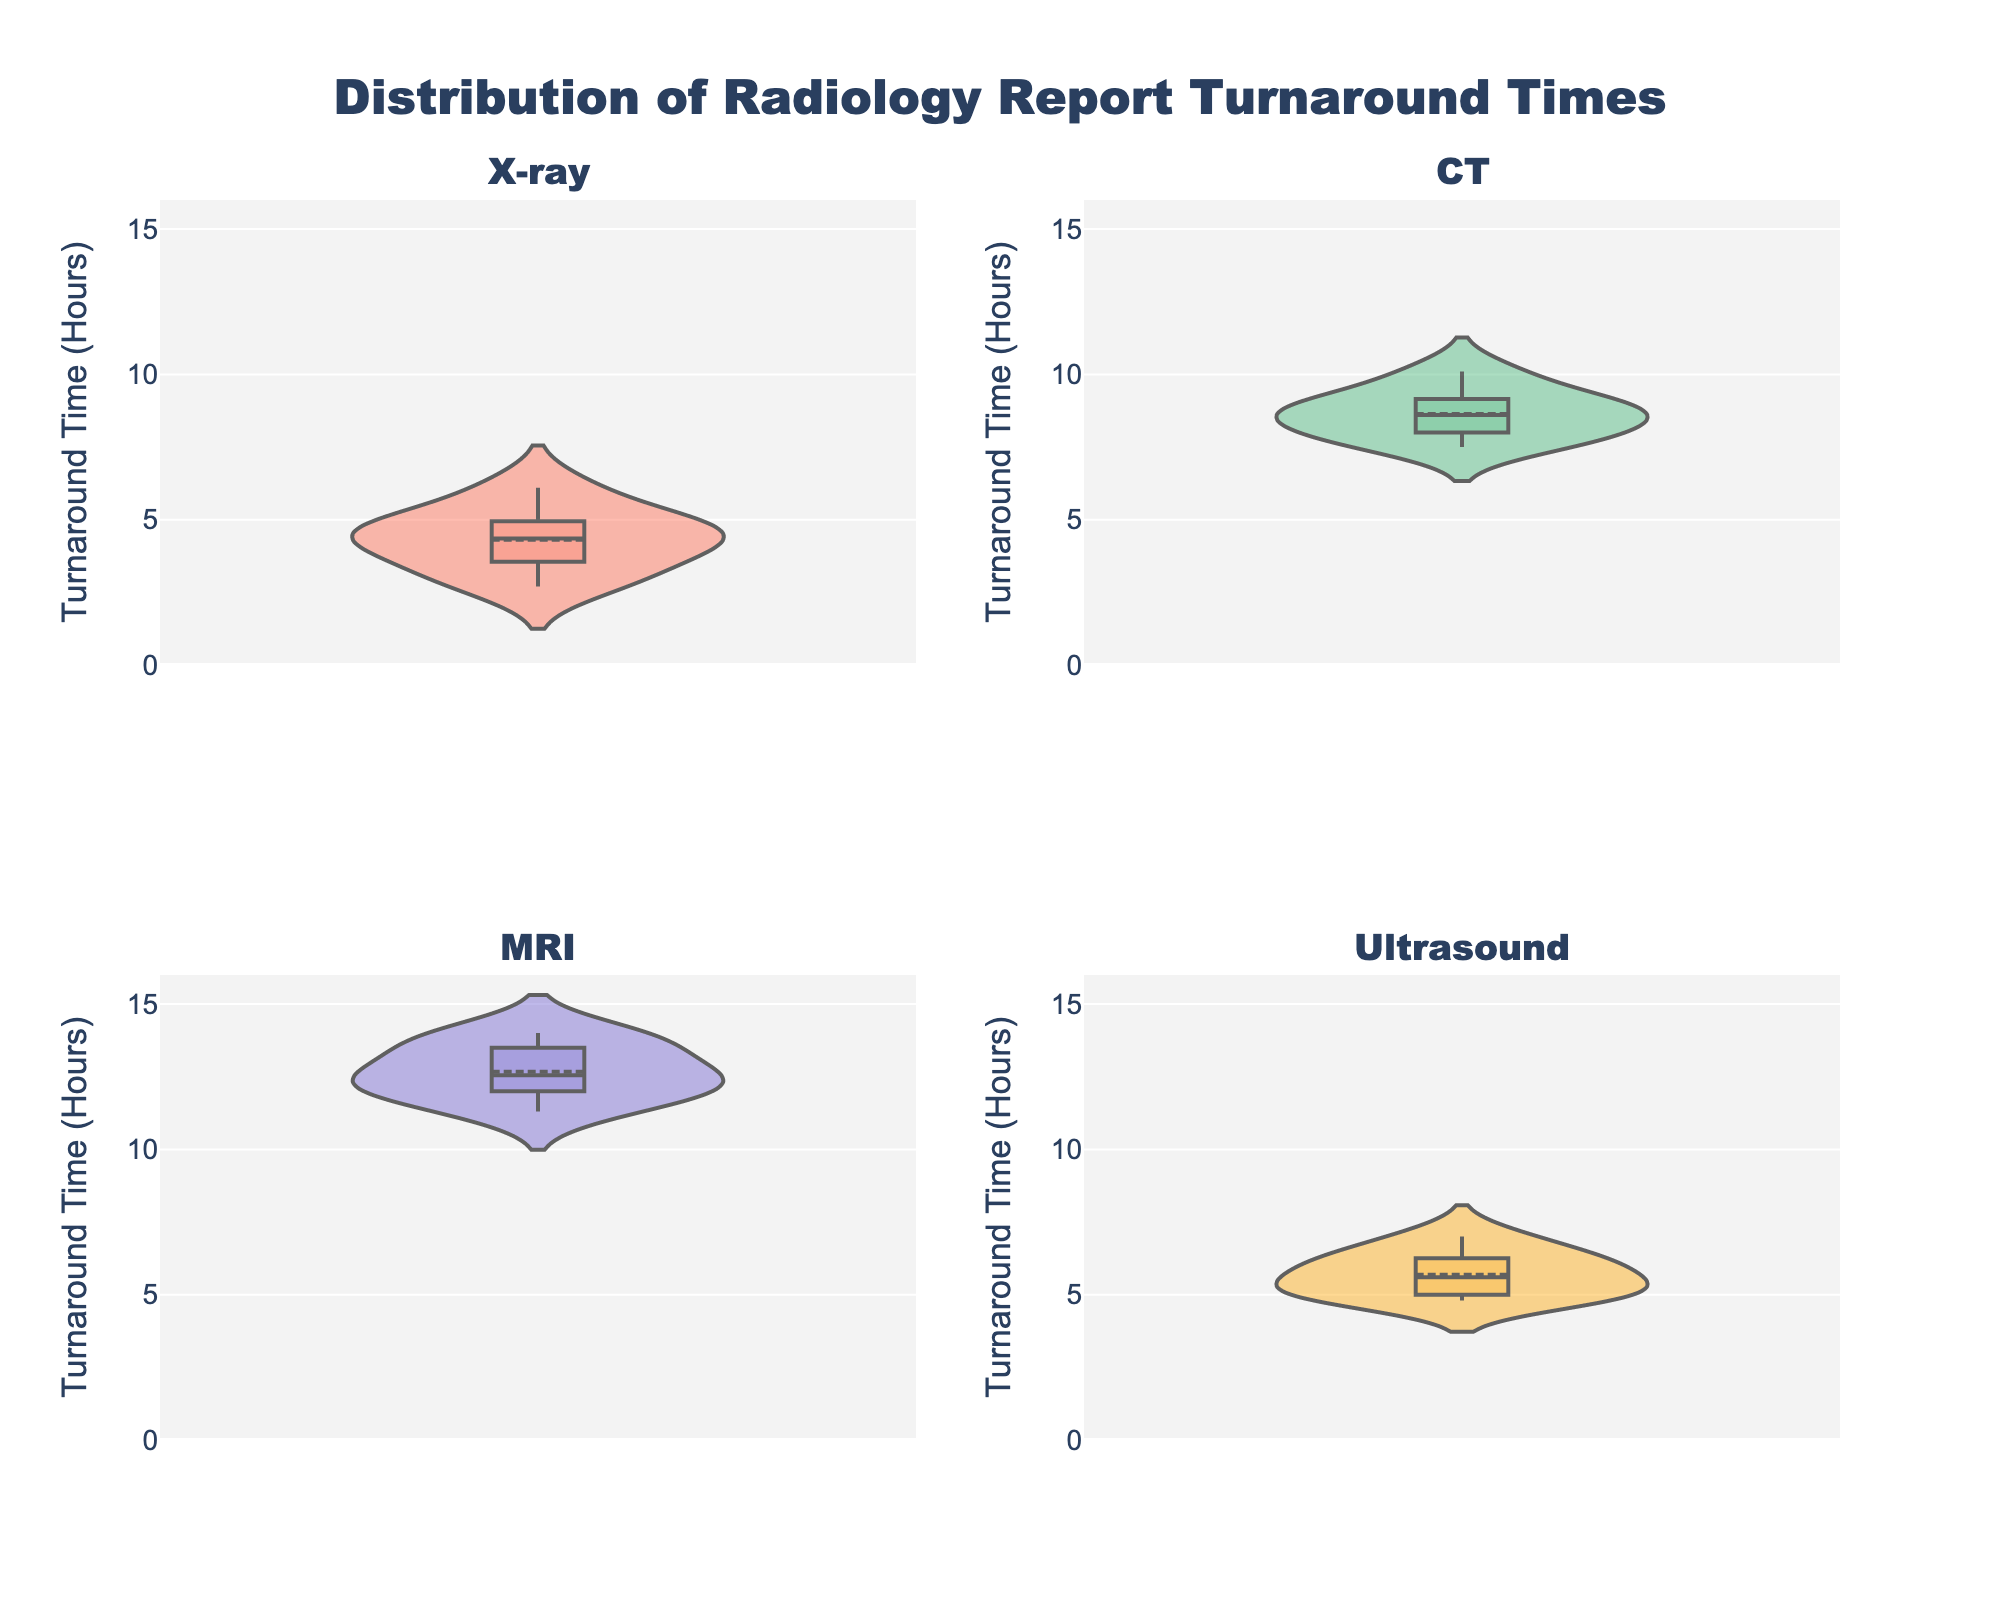What is the title of the figure? The title is usually placed at the top center of the plot and summarizes the main topic of the figure. Look at the text in the title area of the plot.
Answer: Distribution of Radiology Report Turnaround Times What is the range of the y-axis? The range of the y-axis determines the span of values it covers, which is shown next to the y-axis line. Look at the axis and see where it starts and ends.
Answer: 0 to 16 Which modality shows the highest median turnaround time? To find the median turnaround time, look at the white dotted line inside the thick portion of each violin plot. Compare the positions of these lines among the subplots.
Answer: MRI How do the turnaround times of X-ray and Ultrasound compare? Compare the positions and shapes of the violin plots for X-ray and Ultrasound. Look at the spread and central tendency (median) of each plot.
Answer: X-ray times are generally lower and more narrowly spread than Ultrasound What is the fill color for the CT modality subplot? The colors of each subplot can be identified visually. Look at the violin plot labeled "CT" and note its color.
Answer: Light green Which modality has the widest spread of turnaround times? The spread of the violin plot indicates variability in the turnaround times. Observe which plot stretches the most vertically from top to bottom.
Answer: MRI Calculate the difference between the highest turnaround time in the CT modality and the lowest turnaround time in the MRI modality. First, find the maximum value in the CT subplot and the minimum value in the MRI subplot. Subtract the lowest MRI value from the highest CT value.
Answer: 10.1 - 11.3 = -1.2 Which box has the smallest range between the interquartile range (IQR)? The IQR is the range between the first and third quartiles, represented by the thick portion of the violin plot. Observing the plot with the shortest thick portion gives the answer.
Answer: Ultrasound Is the mean line visible for all modalities? The mean line is indicated by a solid horizontal line inside each violin plot. Check every subplot to see if each one includes this line.
Answer: Yes What is the approximate maximum turnaround time for MRI? The maximum turnaround time for MRI is indicated by the upper end of the violin plot for MRI.
Answer: Approximately 14 hours 